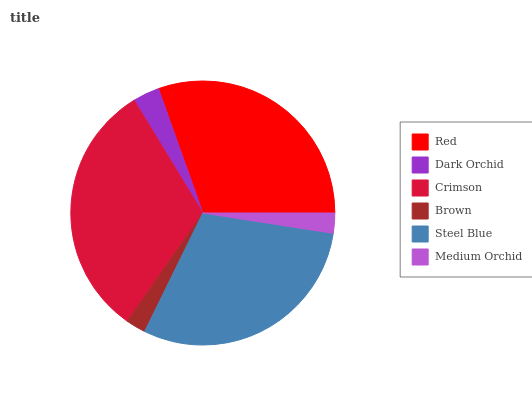Is Brown the minimum?
Answer yes or no. Yes. Is Crimson the maximum?
Answer yes or no. Yes. Is Dark Orchid the minimum?
Answer yes or no. No. Is Dark Orchid the maximum?
Answer yes or no. No. Is Red greater than Dark Orchid?
Answer yes or no. Yes. Is Dark Orchid less than Red?
Answer yes or no. Yes. Is Dark Orchid greater than Red?
Answer yes or no. No. Is Red less than Dark Orchid?
Answer yes or no. No. Is Steel Blue the high median?
Answer yes or no. Yes. Is Dark Orchid the low median?
Answer yes or no. Yes. Is Brown the high median?
Answer yes or no. No. Is Steel Blue the low median?
Answer yes or no. No. 